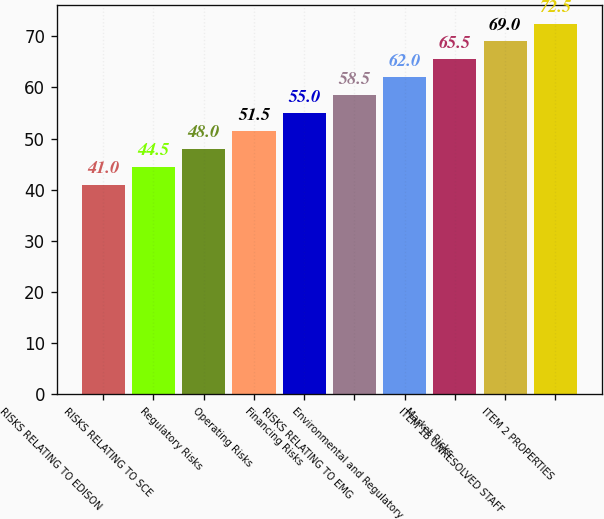<chart> <loc_0><loc_0><loc_500><loc_500><bar_chart><fcel>RISKS RELATING TO EDISON<fcel>RISKS RELATING TO SCE<fcel>Regulatory Risks<fcel>Operating Risks<fcel>Financing Risks<fcel>RISKS RELATING TO EMG<fcel>Environmental and Regulatory<fcel>Market Risks<fcel>ITEM 1B UNRESOLVED STAFF<fcel>ITEM 2 PROPERTIES<nl><fcel>41<fcel>44.5<fcel>48<fcel>51.5<fcel>55<fcel>58.5<fcel>62<fcel>65.5<fcel>69<fcel>72.5<nl></chart> 